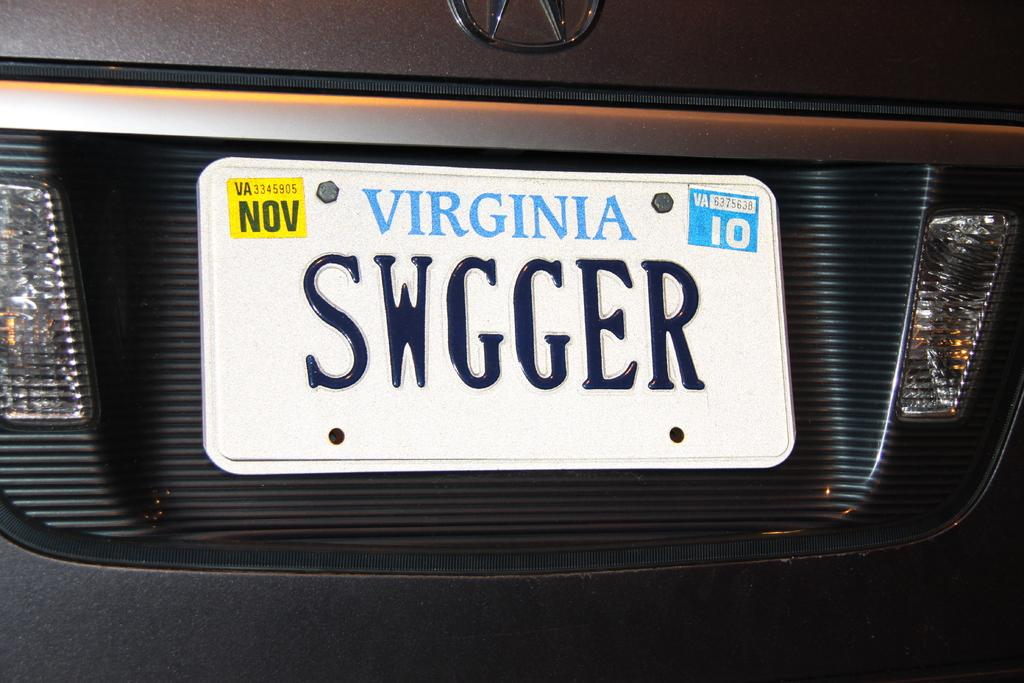Provide a one-sentence caption for the provided image. A Virginia license plate has November tags and says SWGGER. 